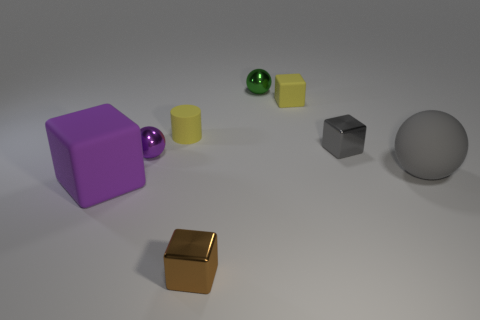Subtract all red cubes. Subtract all purple cylinders. How many cubes are left? 4 Add 1 gray blocks. How many objects exist? 9 Subtract all cylinders. How many objects are left? 7 Add 5 purple matte spheres. How many purple matte spheres exist? 5 Subtract 0 purple cylinders. How many objects are left? 8 Subtract all big yellow matte cylinders. Subtract all big cubes. How many objects are left? 7 Add 6 tiny gray metallic things. How many tiny gray metallic things are left? 7 